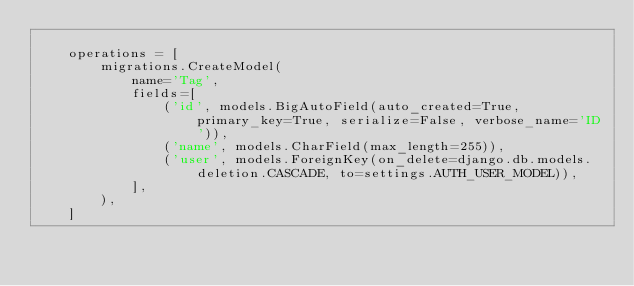Convert code to text. <code><loc_0><loc_0><loc_500><loc_500><_Python_>
    operations = [
        migrations.CreateModel(
            name='Tag',
            fields=[
                ('id', models.BigAutoField(auto_created=True, primary_key=True, serialize=False, verbose_name='ID')),
                ('name', models.CharField(max_length=255)),
                ('user', models.ForeignKey(on_delete=django.db.models.deletion.CASCADE, to=settings.AUTH_USER_MODEL)),
            ],
        ),
    ]
</code> 